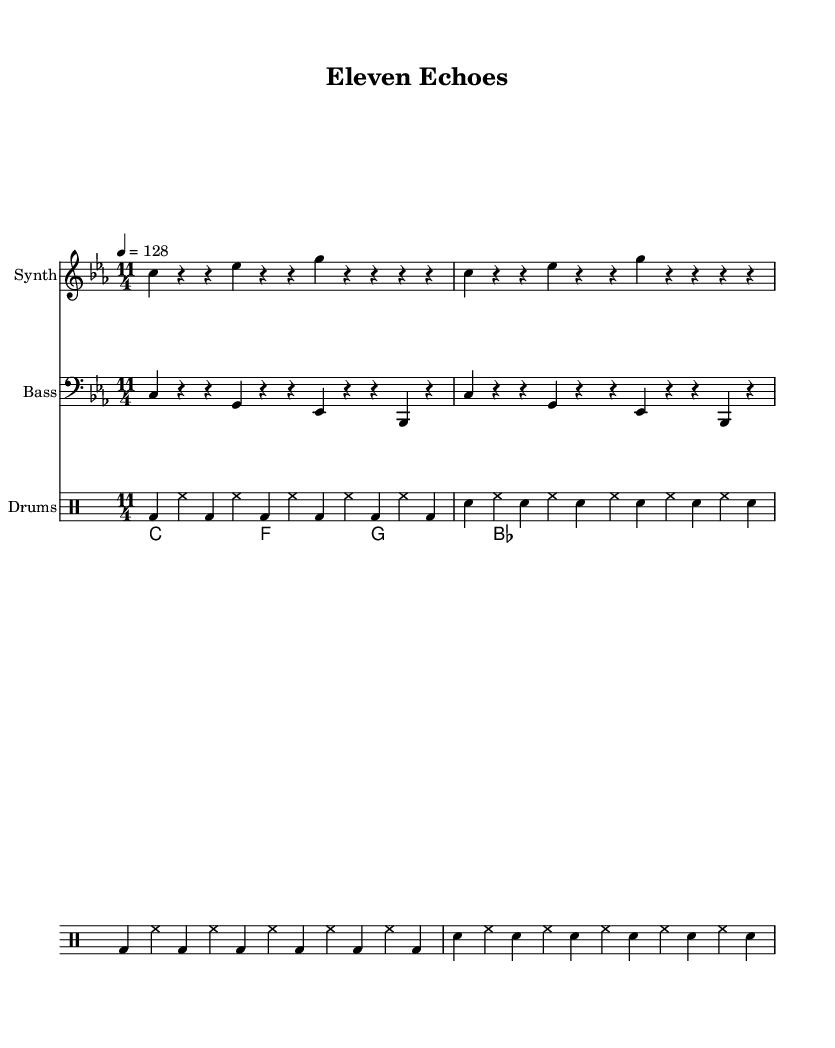What is the time signature of this music? The time signature is indicated at the beginning of the staff as "11/4", meaning there are 11 beats in each measure.
Answer: 11/4 What is the key signature of this music? The key signature is indicated by the key signature symbol at the beginning of the staff and shows a C minor key, which includes three flats (B♭, E♭, A♭).
Answer: C minor What is the tempo marking? The tempo marking is given as "4 = 128", indicating that there should be 128 beats per minute, with the quarter note receiving one beat.
Answer: 128 How many measures are repeated in the synth melody? The synth melody notation shows the repeat sign mentioned twice, indicating that a total of 2 measures are repeated within the melody section.
Answer: 2 How many different drum sounds are present in the drum pattern? The drum pattern shows a bass drum (bd) and a snare (sn), meaning there are 2 distinct sounds presented in this section.
Answer: 2 What is the structure of the bassline? The bassline consists of a repeating pattern of notes (c, g, es, bes), creating a simple but effective rhythmic structure typical in house music.
Answer: Repeating pattern What harmony is used in the piano chords? The piano chords show a combination of four different harmonies: C minor, F minor, G major, and B♭ major all indicated on whole notes, typical in house tracks to create a rich harmonic texture.
Answer: C minor, F minor, G major, B♭ major 